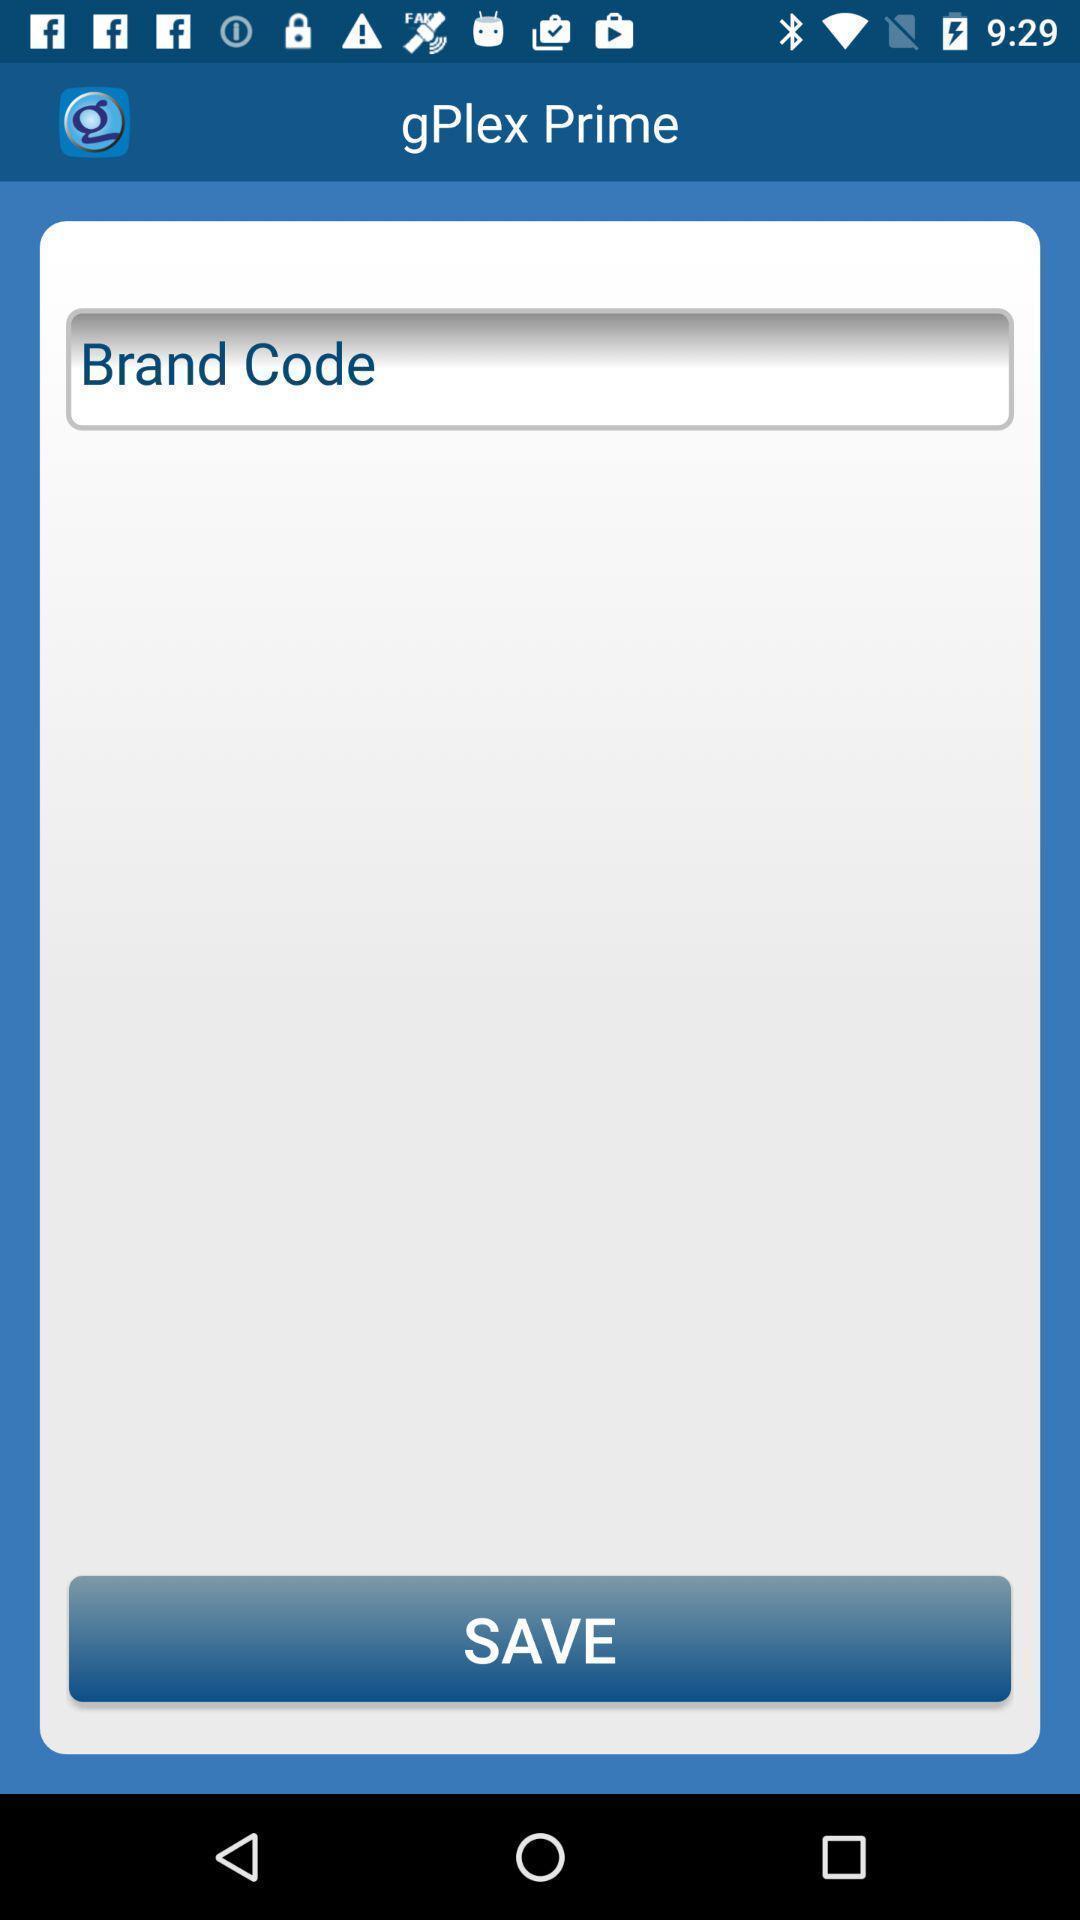Provide a textual representation of this image. Page showing an option and a save button. 